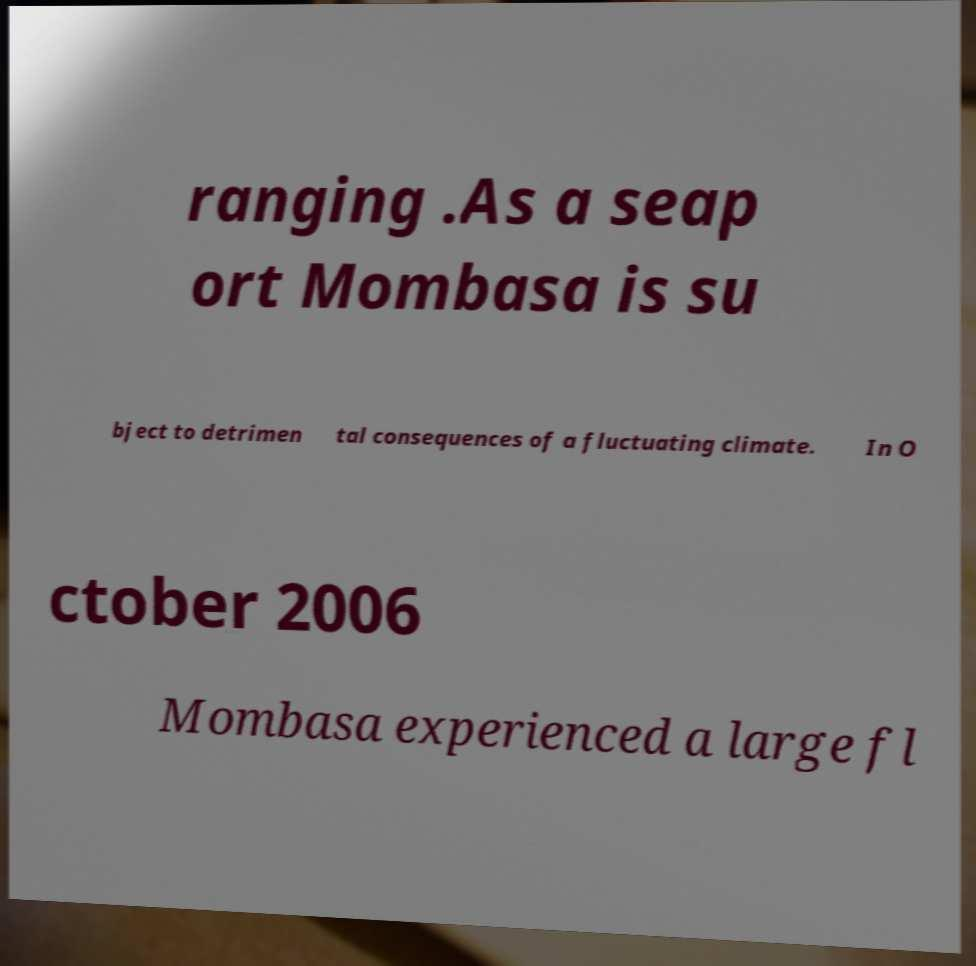Can you accurately transcribe the text from the provided image for me? ranging .As a seap ort Mombasa is su bject to detrimen tal consequences of a fluctuating climate. In O ctober 2006 Mombasa experienced a large fl 